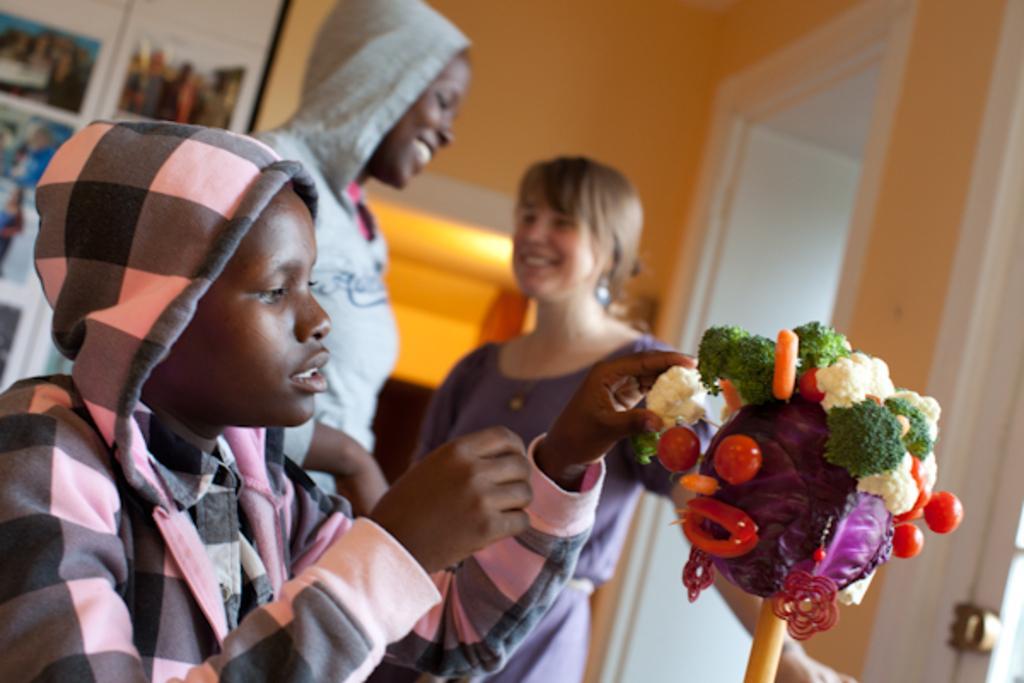How would you summarize this image in a sentence or two? In this picture we can see group of people, on the right side of the image we can find few vegetables, in the background we can see a light and few frames on the wall. 